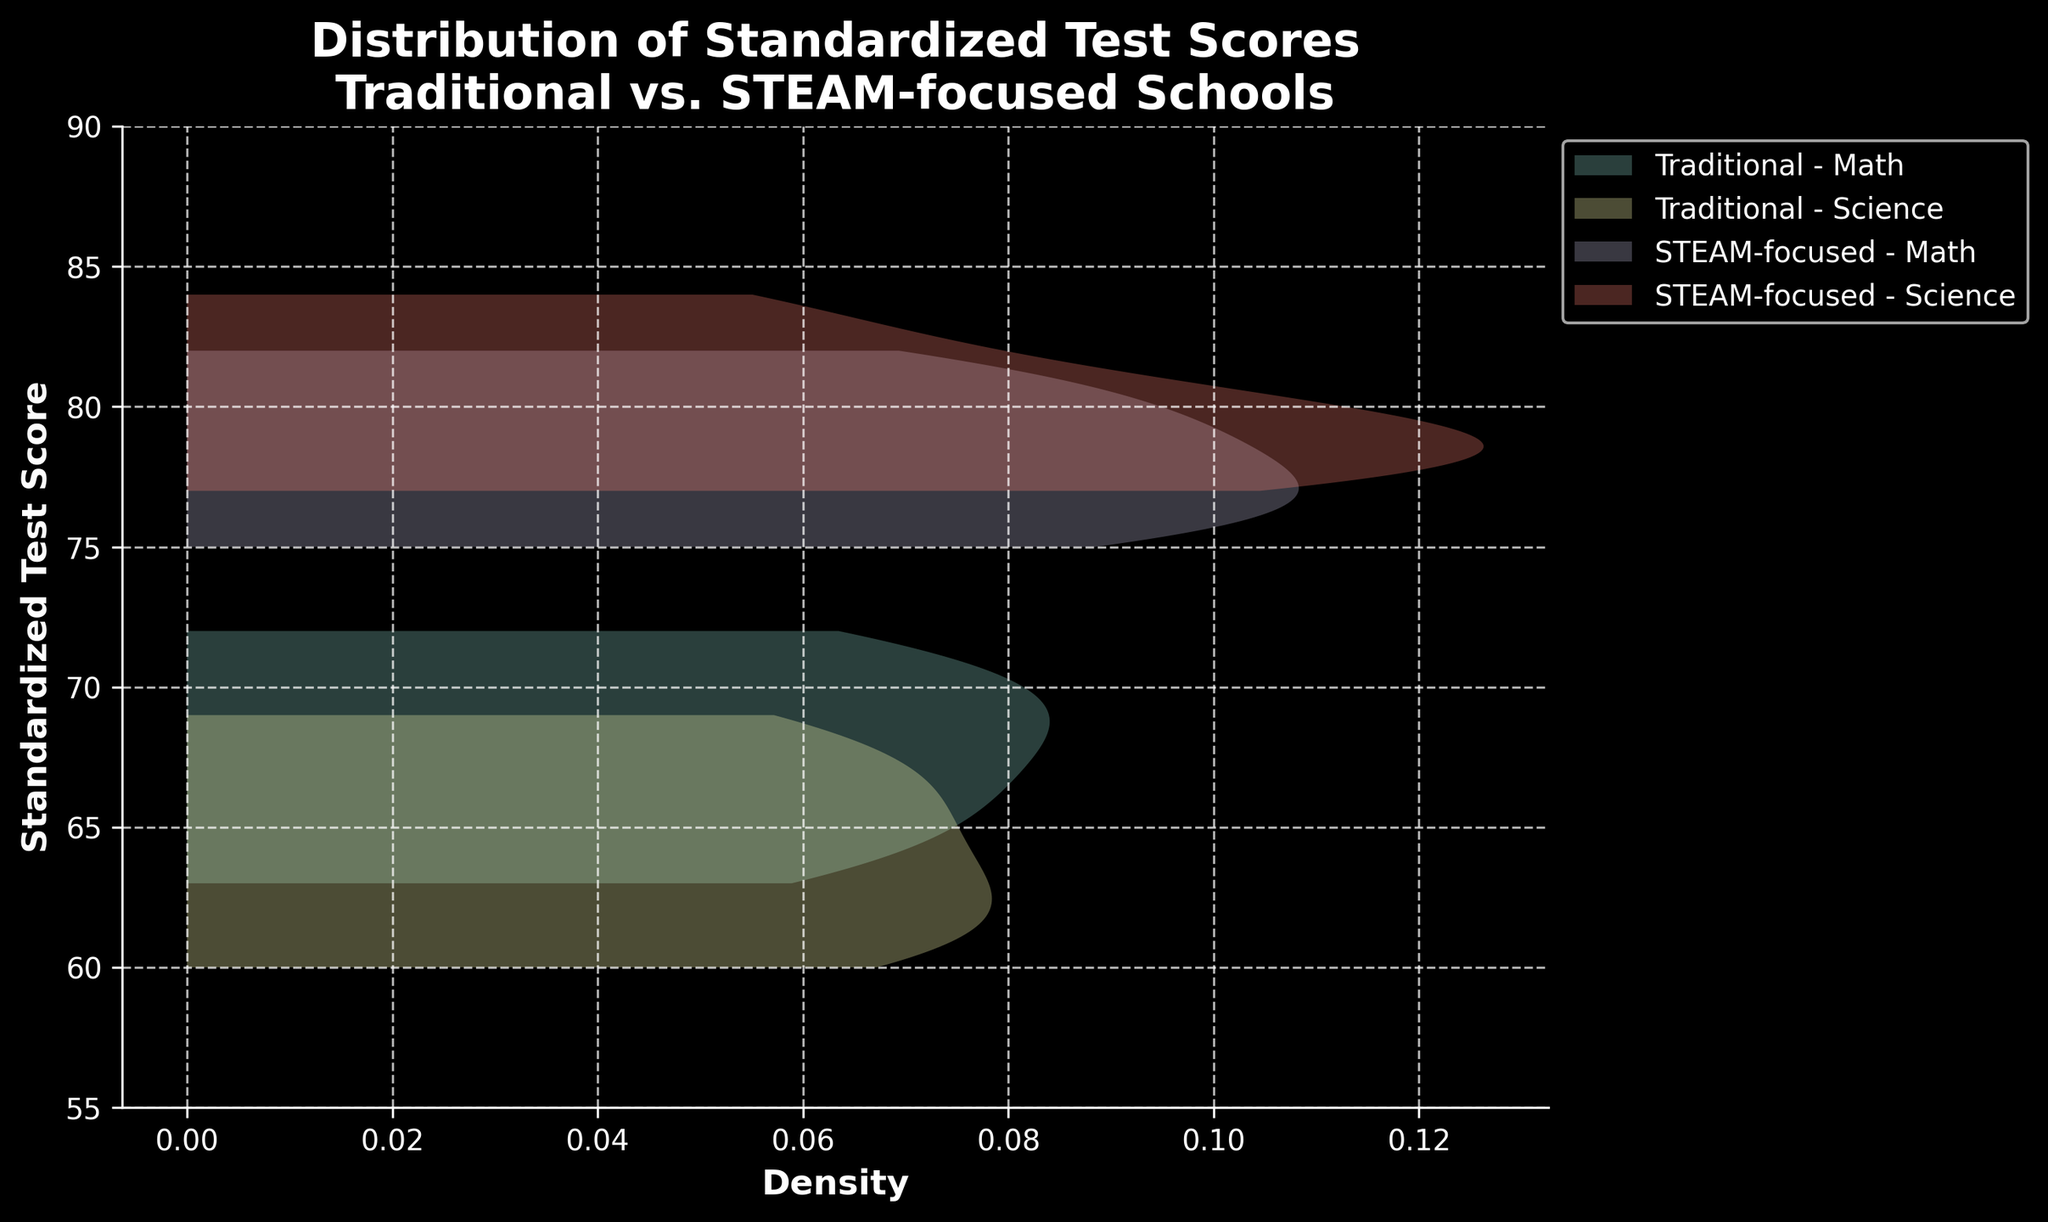How many different school types are displayed in the plot? There are two school types shown in the plot: Traditional and STEAM-focused. This is evident from the labels in the legend.
Answer: 2 Which subject shows higher test scores in the STEAM-focused schools? To determine this, compare the density curves for the Math and Science subjects within the STEAM-focused school type. The density curve for Science is centered around higher scores than Math.
Answer: Science What is the title of the plot? The title of the plot can be found at the top of the figure. It is "Distribution of Standardized Test Scores\nTraditional vs. STEAM-focused Schools."
Answer: Distribution of Standardized Test Scores\nTraditional vs. STEAM-focused Schools What is the y-axis range of the plot? The y-axis range is given by the values at the bottom and top ends of the y-axis line, which are labeled. The range is from 55 to 90.
Answer: 55 to 90 Which school type and subject combination has the narrowest spread of scores? To determine which combination has the narrowest spread, look at the width of the density curves. The narrower the peak, the smaller the spread. The STEAM-focused Math subject has a narrower peak compared to others.
Answer: STEAM-focused Math Between the Traditional and STEAM-focused schools, which has a higher density around the score of 70 for Math? To compare, observe the density curves for Math around the score of 70. The Traditional schools show a higher density around this score.
Answer: Traditional Which subject in Traditional schools shows more variance in test scores? To observe variance, look at the spread of the density curves. A wider spread indicates more variance. The Science density curve is wider compared to Math in Traditional schools.
Answer: Science What is the lowest score observed in the Traditional schools for Science? The density curve for Traditional Science starts around a score of 60 on the y-axis, indicating this is the lowest observed score.
Answer: 60 Do STEAM-focused schools show a higher density of scores around 80 for Math compared to Traditional schools? Analyze the density of the two curves around the score of 80. The density for STEAM-focused schools in Math is higher around this score compared to Traditional schools.
Answer: Yes What is the general trend in scores for STEAM-focused schools in Science? By observing the density curve for STEAM-focused schools in Science, the trend shows higher concentration and density around higher scores, peaking near scores of 78-84.
Answer: Higher scores 